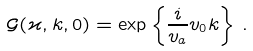Convert formula to latex. <formula><loc_0><loc_0><loc_500><loc_500>\mathcal { G } ( \varkappa , k , 0 ) = \exp \left \{ \frac { i } { v _ { a } } v _ { 0 } k \right \} \, .</formula> 